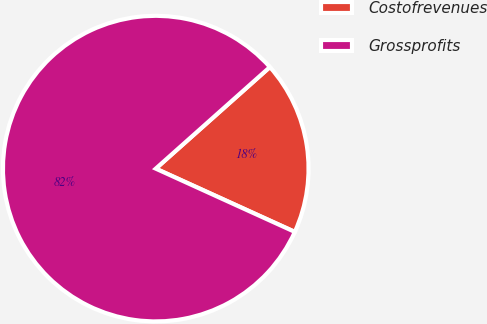Convert chart. <chart><loc_0><loc_0><loc_500><loc_500><pie_chart><fcel>Costofrevenues<fcel>Grossprofits<nl><fcel>18.37%<fcel>81.63%<nl></chart> 